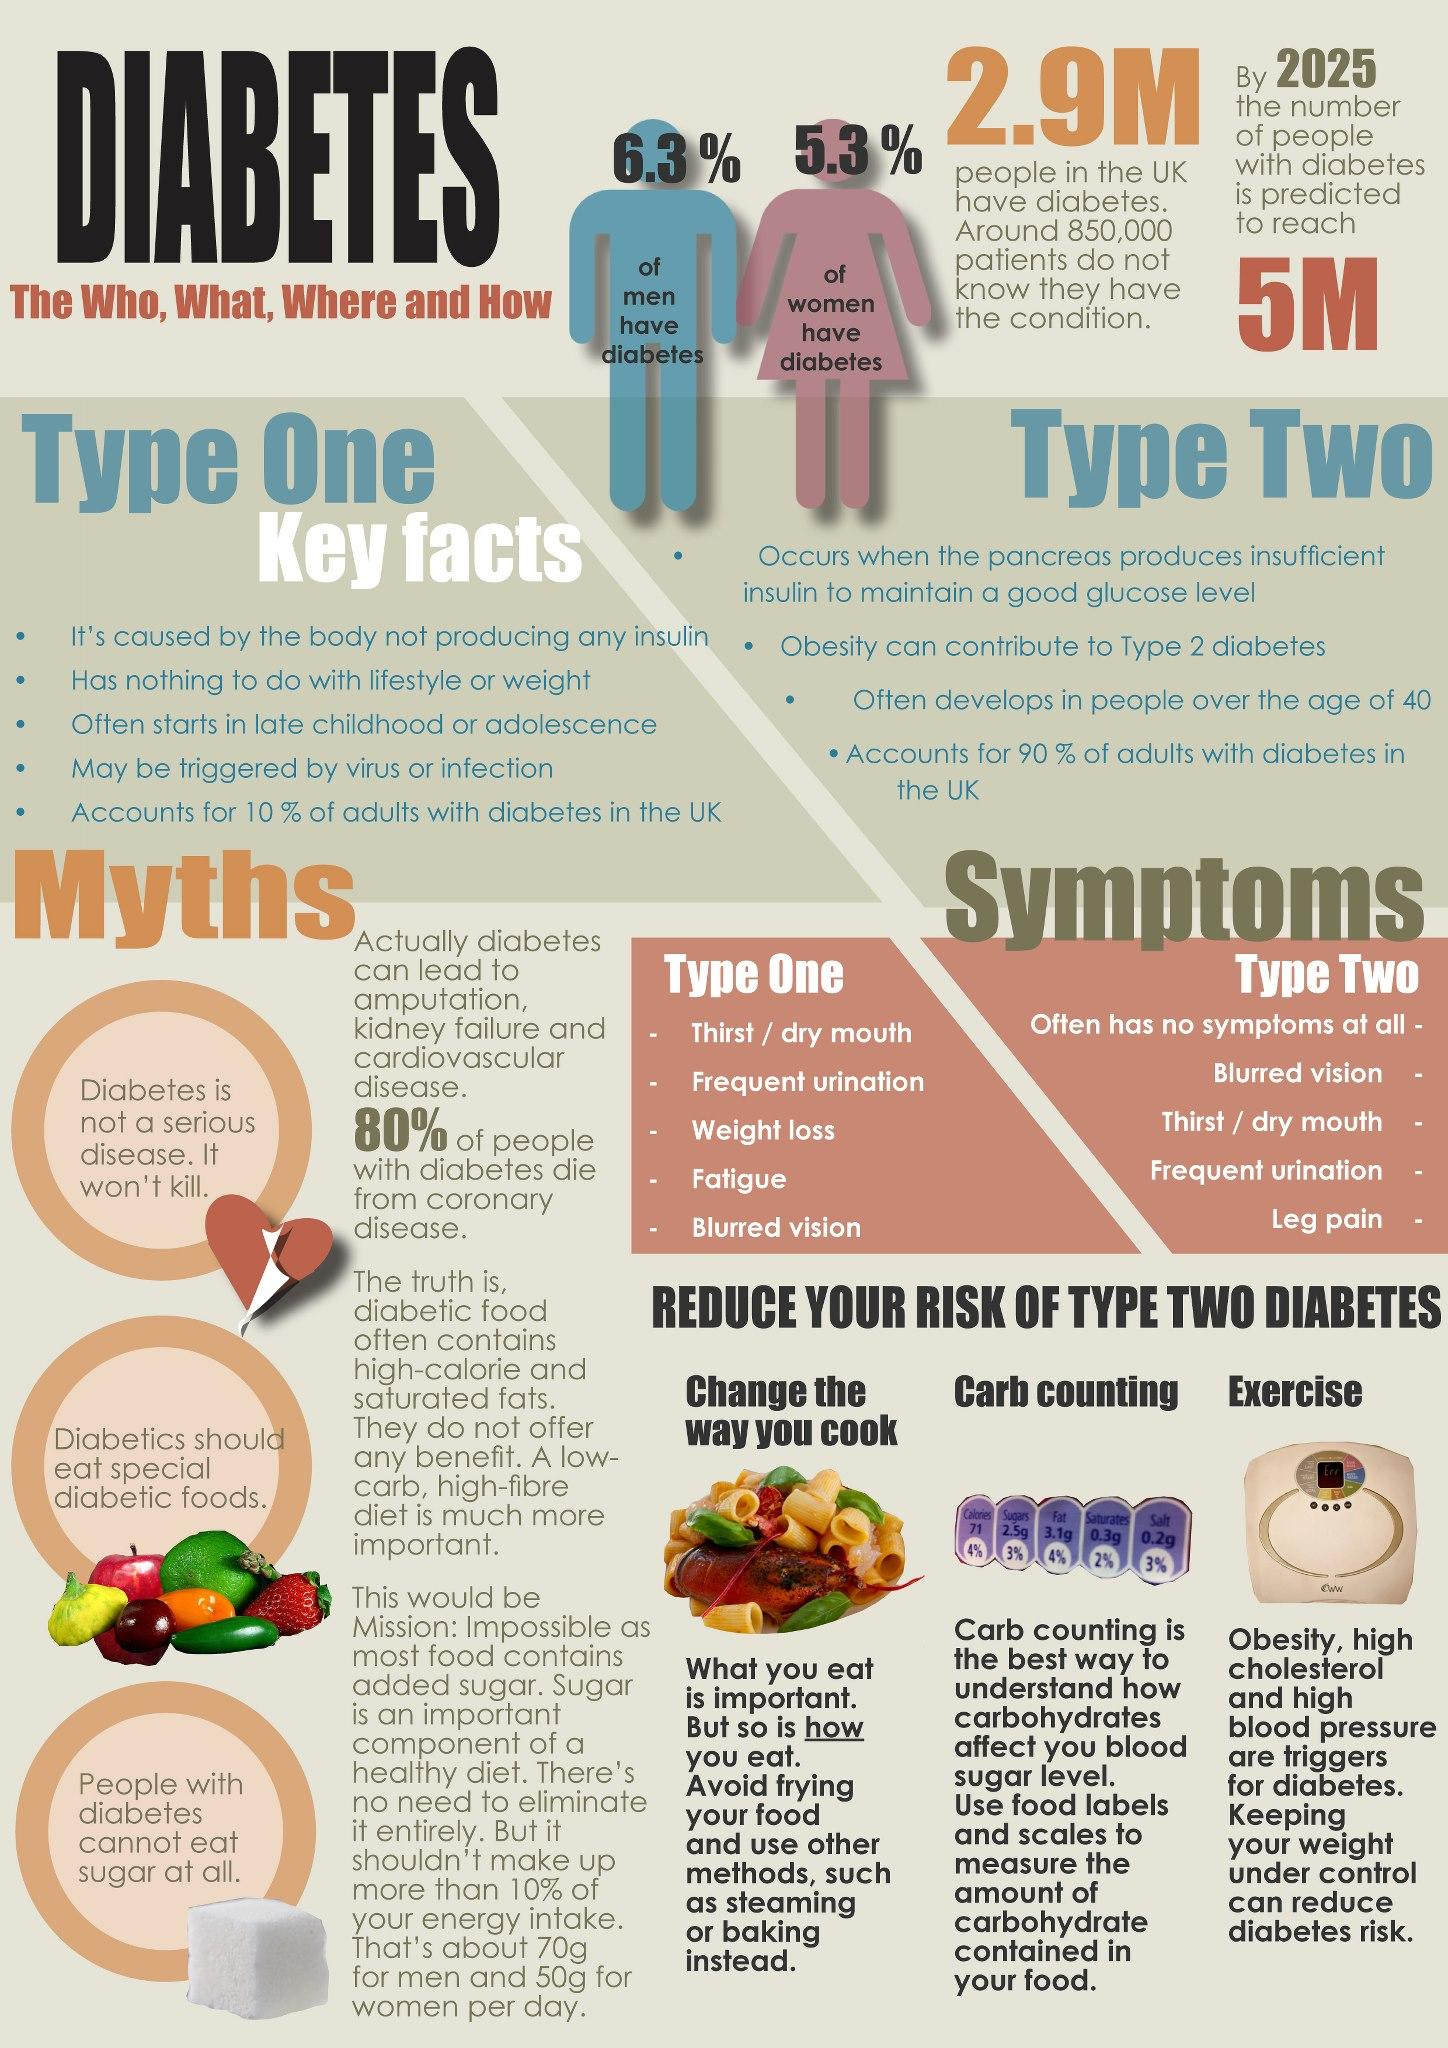Indicate a few pertinent items in this graphic. Men are more likely to develop diabetes than women. There are three myths about diabetes depicted in the graphics. Third in the list of key facts of type two is that Alzheimer's disease, often develops in people over the age of 40. Diabetics are often told that they must consume specific diabetic foods in order to manage their condition effectively, but this is a myth. The fourth key fact of type one is that it may be triggered by a virus or infection. 